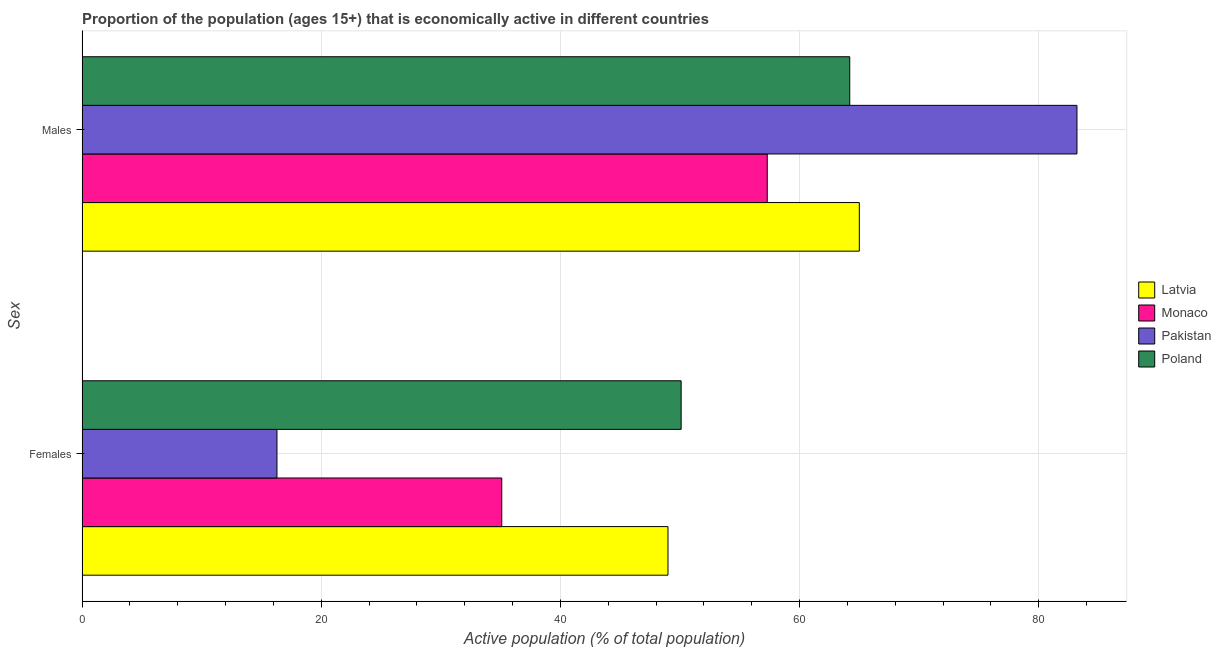How many groups of bars are there?
Make the answer very short. 2. Are the number of bars per tick equal to the number of legend labels?
Make the answer very short. Yes. How many bars are there on the 1st tick from the top?
Make the answer very short. 4. How many bars are there on the 1st tick from the bottom?
Give a very brief answer. 4. What is the label of the 2nd group of bars from the top?
Your answer should be compact. Females. What is the percentage of economically active male population in Pakistan?
Your answer should be very brief. 83.2. Across all countries, what is the maximum percentage of economically active female population?
Ensure brevity in your answer.  50.1. Across all countries, what is the minimum percentage of economically active male population?
Your answer should be compact. 57.3. What is the total percentage of economically active male population in the graph?
Make the answer very short. 269.7. What is the difference between the percentage of economically active female population in Poland and that in Pakistan?
Make the answer very short. 33.8. What is the difference between the percentage of economically active female population in Poland and the percentage of economically active male population in Latvia?
Make the answer very short. -14.9. What is the average percentage of economically active female population per country?
Your answer should be compact. 37.62. What is the difference between the percentage of economically active female population and percentage of economically active male population in Pakistan?
Give a very brief answer. -66.9. What is the ratio of the percentage of economically active male population in Latvia to that in Pakistan?
Ensure brevity in your answer.  0.78. Is the percentage of economically active male population in Pakistan less than that in Latvia?
Keep it short and to the point. No. What does the 4th bar from the top in Females represents?
Your response must be concise. Latvia. How many bars are there?
Ensure brevity in your answer.  8. Are all the bars in the graph horizontal?
Your answer should be very brief. Yes. How many countries are there in the graph?
Your response must be concise. 4. Does the graph contain grids?
Keep it short and to the point. Yes. How many legend labels are there?
Provide a short and direct response. 4. How are the legend labels stacked?
Provide a succinct answer. Vertical. What is the title of the graph?
Your answer should be very brief. Proportion of the population (ages 15+) that is economically active in different countries. What is the label or title of the X-axis?
Ensure brevity in your answer.  Active population (% of total population). What is the label or title of the Y-axis?
Your response must be concise. Sex. What is the Active population (% of total population) of Latvia in Females?
Offer a very short reply. 49. What is the Active population (% of total population) in Monaco in Females?
Ensure brevity in your answer.  35.1. What is the Active population (% of total population) of Pakistan in Females?
Keep it short and to the point. 16.3. What is the Active population (% of total population) of Poland in Females?
Provide a succinct answer. 50.1. What is the Active population (% of total population) of Latvia in Males?
Your response must be concise. 65. What is the Active population (% of total population) of Monaco in Males?
Provide a succinct answer. 57.3. What is the Active population (% of total population) in Pakistan in Males?
Ensure brevity in your answer.  83.2. What is the Active population (% of total population) of Poland in Males?
Offer a terse response. 64.2. Across all Sex, what is the maximum Active population (% of total population) in Latvia?
Your response must be concise. 65. Across all Sex, what is the maximum Active population (% of total population) of Monaco?
Provide a succinct answer. 57.3. Across all Sex, what is the maximum Active population (% of total population) in Pakistan?
Provide a short and direct response. 83.2. Across all Sex, what is the maximum Active population (% of total population) of Poland?
Offer a very short reply. 64.2. Across all Sex, what is the minimum Active population (% of total population) of Monaco?
Provide a short and direct response. 35.1. Across all Sex, what is the minimum Active population (% of total population) of Pakistan?
Offer a terse response. 16.3. Across all Sex, what is the minimum Active population (% of total population) of Poland?
Give a very brief answer. 50.1. What is the total Active population (% of total population) of Latvia in the graph?
Give a very brief answer. 114. What is the total Active population (% of total population) in Monaco in the graph?
Your answer should be very brief. 92.4. What is the total Active population (% of total population) in Pakistan in the graph?
Provide a succinct answer. 99.5. What is the total Active population (% of total population) in Poland in the graph?
Your answer should be compact. 114.3. What is the difference between the Active population (% of total population) of Latvia in Females and that in Males?
Keep it short and to the point. -16. What is the difference between the Active population (% of total population) of Monaco in Females and that in Males?
Provide a succinct answer. -22.2. What is the difference between the Active population (% of total population) of Pakistan in Females and that in Males?
Ensure brevity in your answer.  -66.9. What is the difference between the Active population (% of total population) in Poland in Females and that in Males?
Ensure brevity in your answer.  -14.1. What is the difference between the Active population (% of total population) of Latvia in Females and the Active population (% of total population) of Monaco in Males?
Your response must be concise. -8.3. What is the difference between the Active population (% of total population) of Latvia in Females and the Active population (% of total population) of Pakistan in Males?
Provide a succinct answer. -34.2. What is the difference between the Active population (% of total population) in Latvia in Females and the Active population (% of total population) in Poland in Males?
Make the answer very short. -15.2. What is the difference between the Active population (% of total population) of Monaco in Females and the Active population (% of total population) of Pakistan in Males?
Your response must be concise. -48.1. What is the difference between the Active population (% of total population) in Monaco in Females and the Active population (% of total population) in Poland in Males?
Make the answer very short. -29.1. What is the difference between the Active population (% of total population) in Pakistan in Females and the Active population (% of total population) in Poland in Males?
Offer a terse response. -47.9. What is the average Active population (% of total population) of Monaco per Sex?
Offer a terse response. 46.2. What is the average Active population (% of total population) of Pakistan per Sex?
Ensure brevity in your answer.  49.75. What is the average Active population (% of total population) in Poland per Sex?
Provide a succinct answer. 57.15. What is the difference between the Active population (% of total population) in Latvia and Active population (% of total population) in Monaco in Females?
Ensure brevity in your answer.  13.9. What is the difference between the Active population (% of total population) in Latvia and Active population (% of total population) in Pakistan in Females?
Make the answer very short. 32.7. What is the difference between the Active population (% of total population) in Latvia and Active population (% of total population) in Poland in Females?
Provide a short and direct response. -1.1. What is the difference between the Active population (% of total population) in Monaco and Active population (% of total population) in Poland in Females?
Your answer should be compact. -15. What is the difference between the Active population (% of total population) of Pakistan and Active population (% of total population) of Poland in Females?
Make the answer very short. -33.8. What is the difference between the Active population (% of total population) of Latvia and Active population (% of total population) of Monaco in Males?
Ensure brevity in your answer.  7.7. What is the difference between the Active population (% of total population) in Latvia and Active population (% of total population) in Pakistan in Males?
Make the answer very short. -18.2. What is the difference between the Active population (% of total population) in Latvia and Active population (% of total population) in Poland in Males?
Offer a terse response. 0.8. What is the difference between the Active population (% of total population) of Monaco and Active population (% of total population) of Pakistan in Males?
Offer a very short reply. -25.9. What is the difference between the Active population (% of total population) in Monaco and Active population (% of total population) in Poland in Males?
Make the answer very short. -6.9. What is the ratio of the Active population (% of total population) in Latvia in Females to that in Males?
Give a very brief answer. 0.75. What is the ratio of the Active population (% of total population) in Monaco in Females to that in Males?
Offer a terse response. 0.61. What is the ratio of the Active population (% of total population) in Pakistan in Females to that in Males?
Provide a succinct answer. 0.2. What is the ratio of the Active population (% of total population) of Poland in Females to that in Males?
Keep it short and to the point. 0.78. What is the difference between the highest and the second highest Active population (% of total population) of Pakistan?
Provide a succinct answer. 66.9. What is the difference between the highest and the lowest Active population (% of total population) of Latvia?
Your response must be concise. 16. What is the difference between the highest and the lowest Active population (% of total population) in Monaco?
Keep it short and to the point. 22.2. What is the difference between the highest and the lowest Active population (% of total population) in Pakistan?
Offer a very short reply. 66.9. 